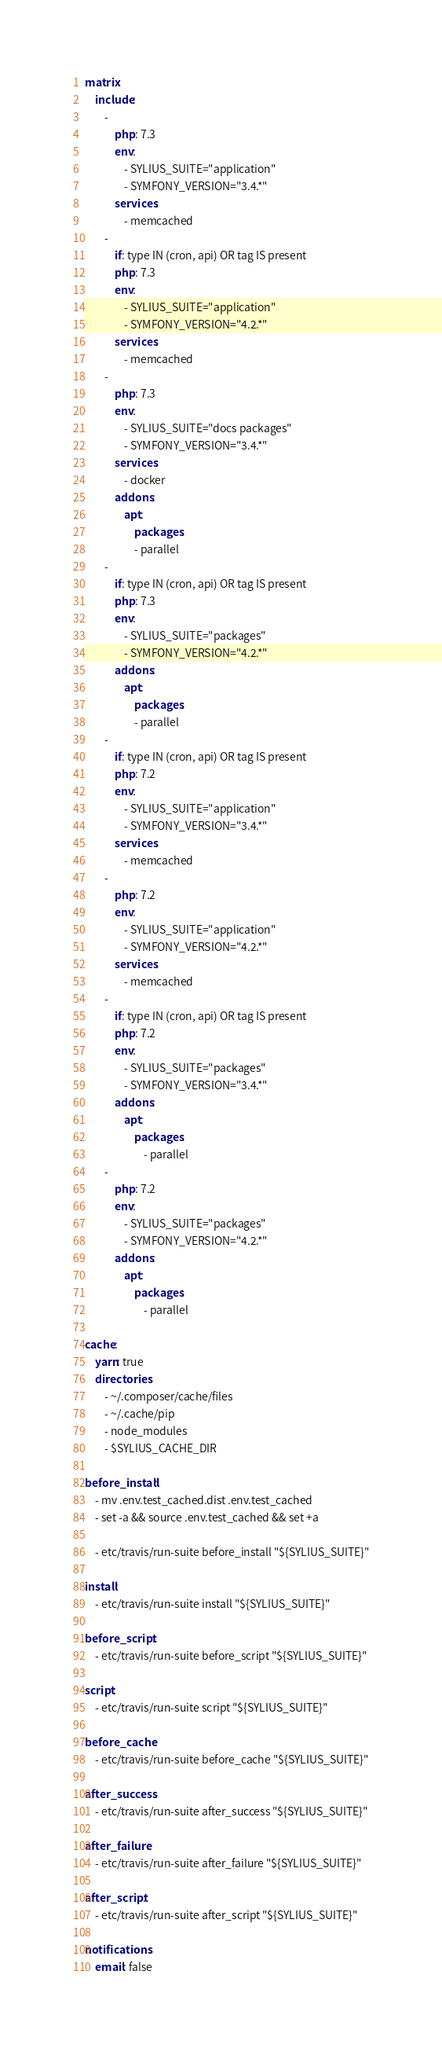Convert code to text. <code><loc_0><loc_0><loc_500><loc_500><_YAML_>matrix:
    include:
        -
            php: 7.3
            env:
                - SYLIUS_SUITE="application"
                - SYMFONY_VERSION="3.4.*"
            services:
                - memcached
        -
            if: type IN (cron, api) OR tag IS present
            php: 7.3
            env:
                - SYLIUS_SUITE="application"
                - SYMFONY_VERSION="4.2.*"
            services:
                - memcached
        -
            php: 7.3
            env:
                - SYLIUS_SUITE="docs packages"
                - SYMFONY_VERSION="3.4.*"
            services:
                - docker
            addons:
                apt:
                    packages:
                    - parallel
        -
            if: type IN (cron, api) OR tag IS present
            php: 7.3
            env:
                - SYLIUS_SUITE="packages"
                - SYMFONY_VERSION="4.2.*"
            addons:
                apt:
                    packages:
                    - parallel
        -
            if: type IN (cron, api) OR tag IS present
            php: 7.2
            env:
                - SYLIUS_SUITE="application"
                - SYMFONY_VERSION="3.4.*"
            services:
                - memcached
        -
            php: 7.2
            env:
                - SYLIUS_SUITE="application"
                - SYMFONY_VERSION="4.2.*"
            services:
                - memcached
        -
            if: type IN (cron, api) OR tag IS present
            php: 7.2
            env:
                - SYLIUS_SUITE="packages"
                - SYMFONY_VERSION="3.4.*"
            addons:
                apt:
                    packages:
                        - parallel
        -
            php: 7.2
            env:
                - SYLIUS_SUITE="packages"
                - SYMFONY_VERSION="4.2.*"
            addons:
                apt:
                    packages:
                        - parallel

cache:
    yarn: true
    directories:
        - ~/.composer/cache/files
        - ~/.cache/pip
        - node_modules
        - $SYLIUS_CACHE_DIR

before_install:
    - mv .env.test_cached.dist .env.test_cached
    - set -a && source .env.test_cached && set +a

    - etc/travis/run-suite before_install "${SYLIUS_SUITE}"

install:
    - etc/travis/run-suite install "${SYLIUS_SUITE}"

before_script:
    - etc/travis/run-suite before_script "${SYLIUS_SUITE}"

script:
    - etc/travis/run-suite script "${SYLIUS_SUITE}"

before_cache:
    - etc/travis/run-suite before_cache "${SYLIUS_SUITE}"

after_success:
    - etc/travis/run-suite after_success "${SYLIUS_SUITE}"

after_failure:
    - etc/travis/run-suite after_failure "${SYLIUS_SUITE}"

after_script:
    - etc/travis/run-suite after_script "${SYLIUS_SUITE}"

notifications:
    email: false
</code> 